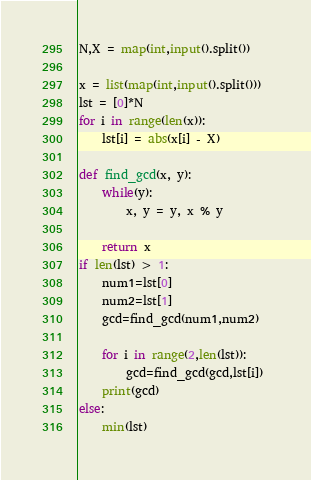Convert code to text. <code><loc_0><loc_0><loc_500><loc_500><_Python_>N,X = map(int,input().split())

x = list(map(int,input().split()))
lst = [0]*N
for i in range(len(x)):
    lst[i] = abs(x[i] - X)
   
def find_gcd(x, y): 
    while(y): 
        x, y = y, x % y 
  
    return x 
if len(lst) > 1:
    num1=lst[0] 
    num2=lst[1] 
    gcd=find_gcd(num1,num2) 
  
    for i in range(2,len(lst)): 
        gcd=find_gcd(gcd,lst[i]) 
    print(gcd)
else:
    min(lst)</code> 